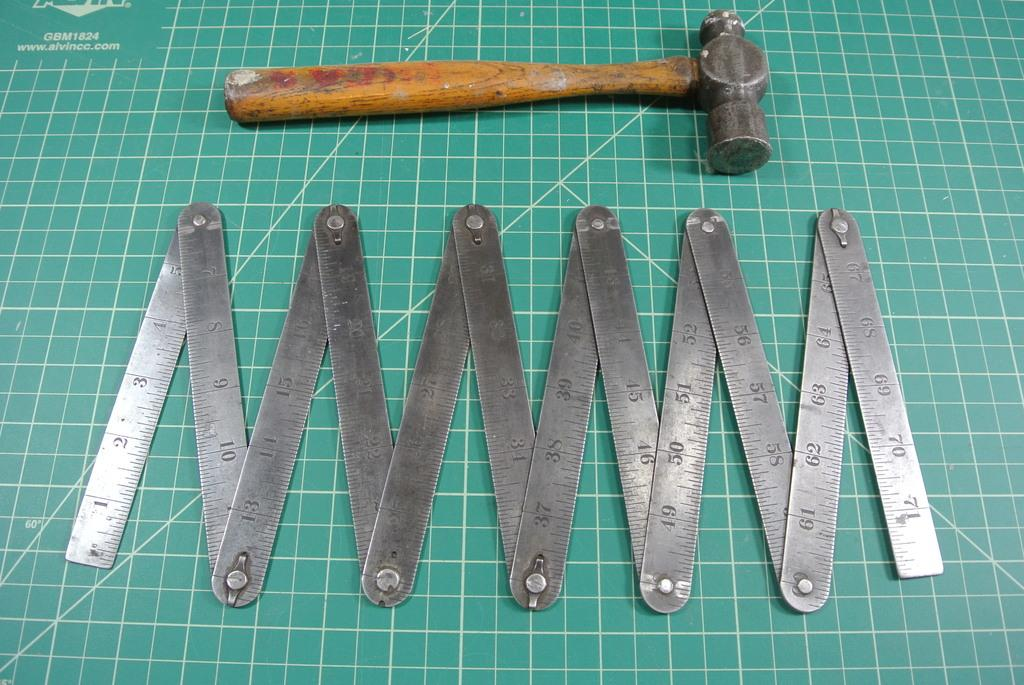<image>
Render a clear and concise summary of the photo. A ball peen hammer and extendable ruler on a sil matt marked GBM1824 in the upper left corner. 